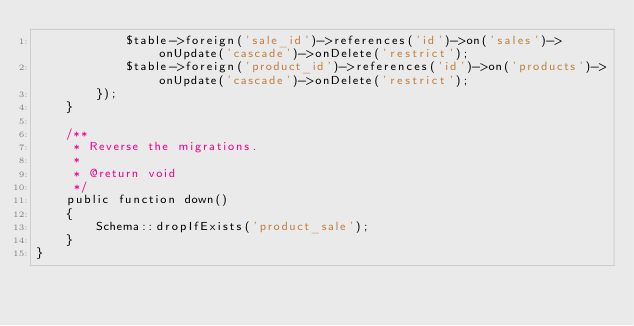Convert code to text. <code><loc_0><loc_0><loc_500><loc_500><_PHP_>            $table->foreign('sale_id')->references('id')->on('sales')->onUpdate('cascade')->onDelete('restrict');
            $table->foreign('product_id')->references('id')->on('products')->onUpdate('cascade')->onDelete('restrict');
        });
    }

    /**
     * Reverse the migrations.
     *
     * @return void
     */
    public function down()
    {
        Schema::dropIfExists('product_sale');
    }
}
</code> 